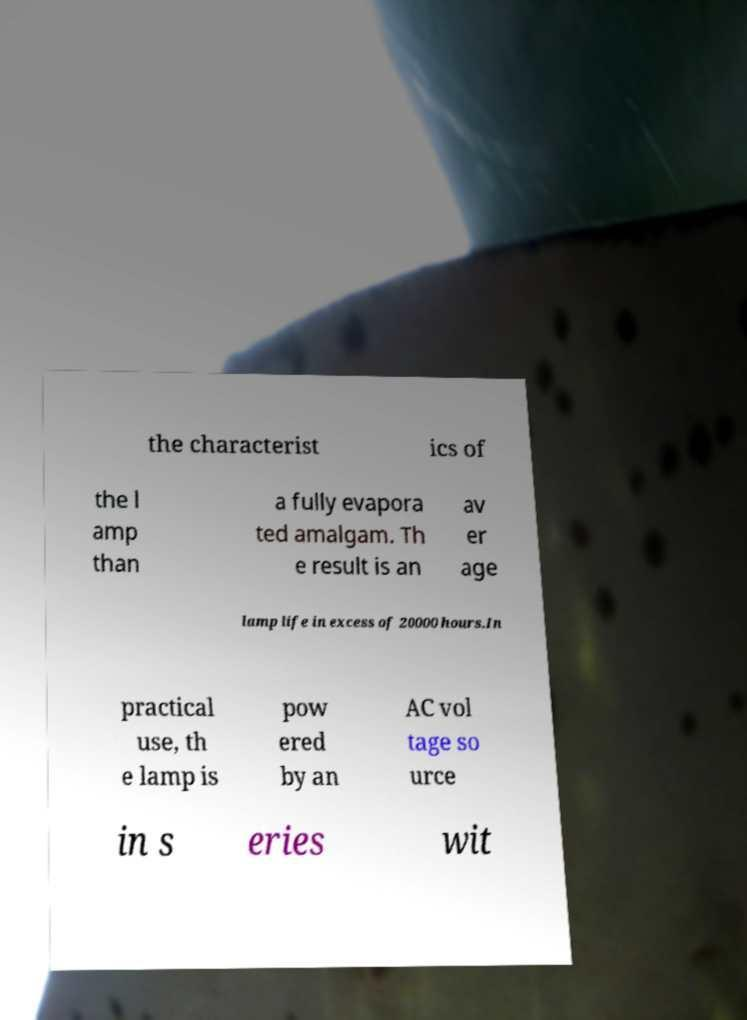Could you extract and type out the text from this image? the characterist ics of the l amp than a fully evapora ted amalgam. Th e result is an av er age lamp life in excess of 20000 hours.In practical use, th e lamp is pow ered by an AC vol tage so urce in s eries wit 